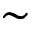<formula> <loc_0><loc_0><loc_500><loc_500>\sim</formula> 